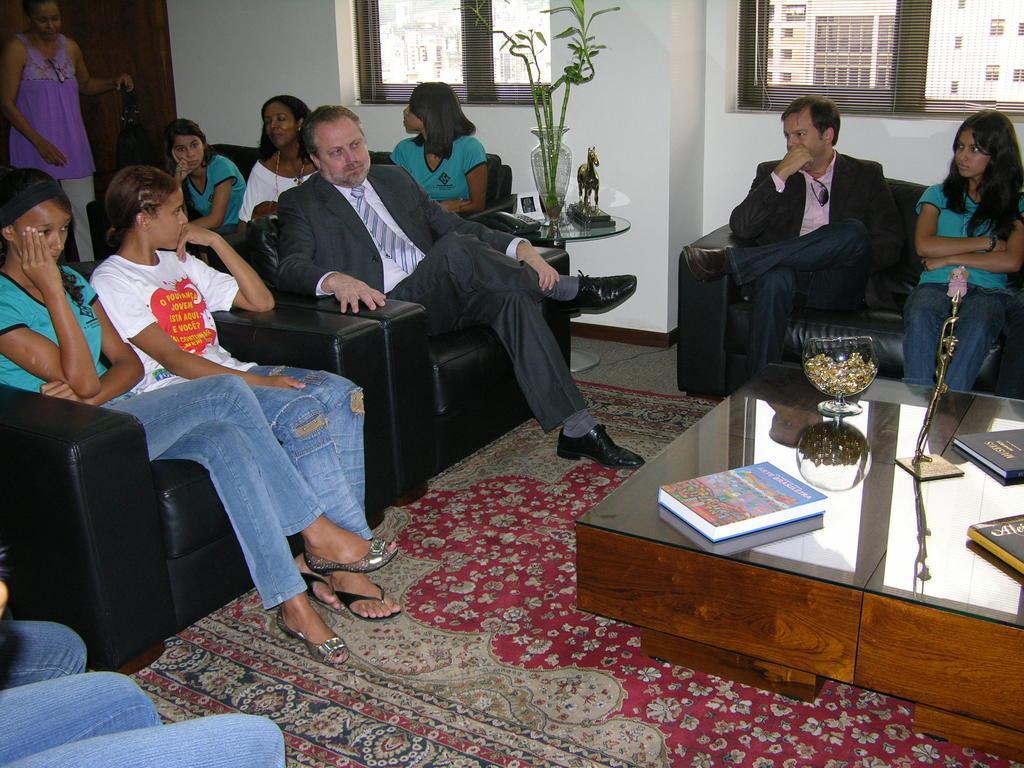Could you give a brief overview of what you see in this image? People are sitting in sofas in a waiting room. 